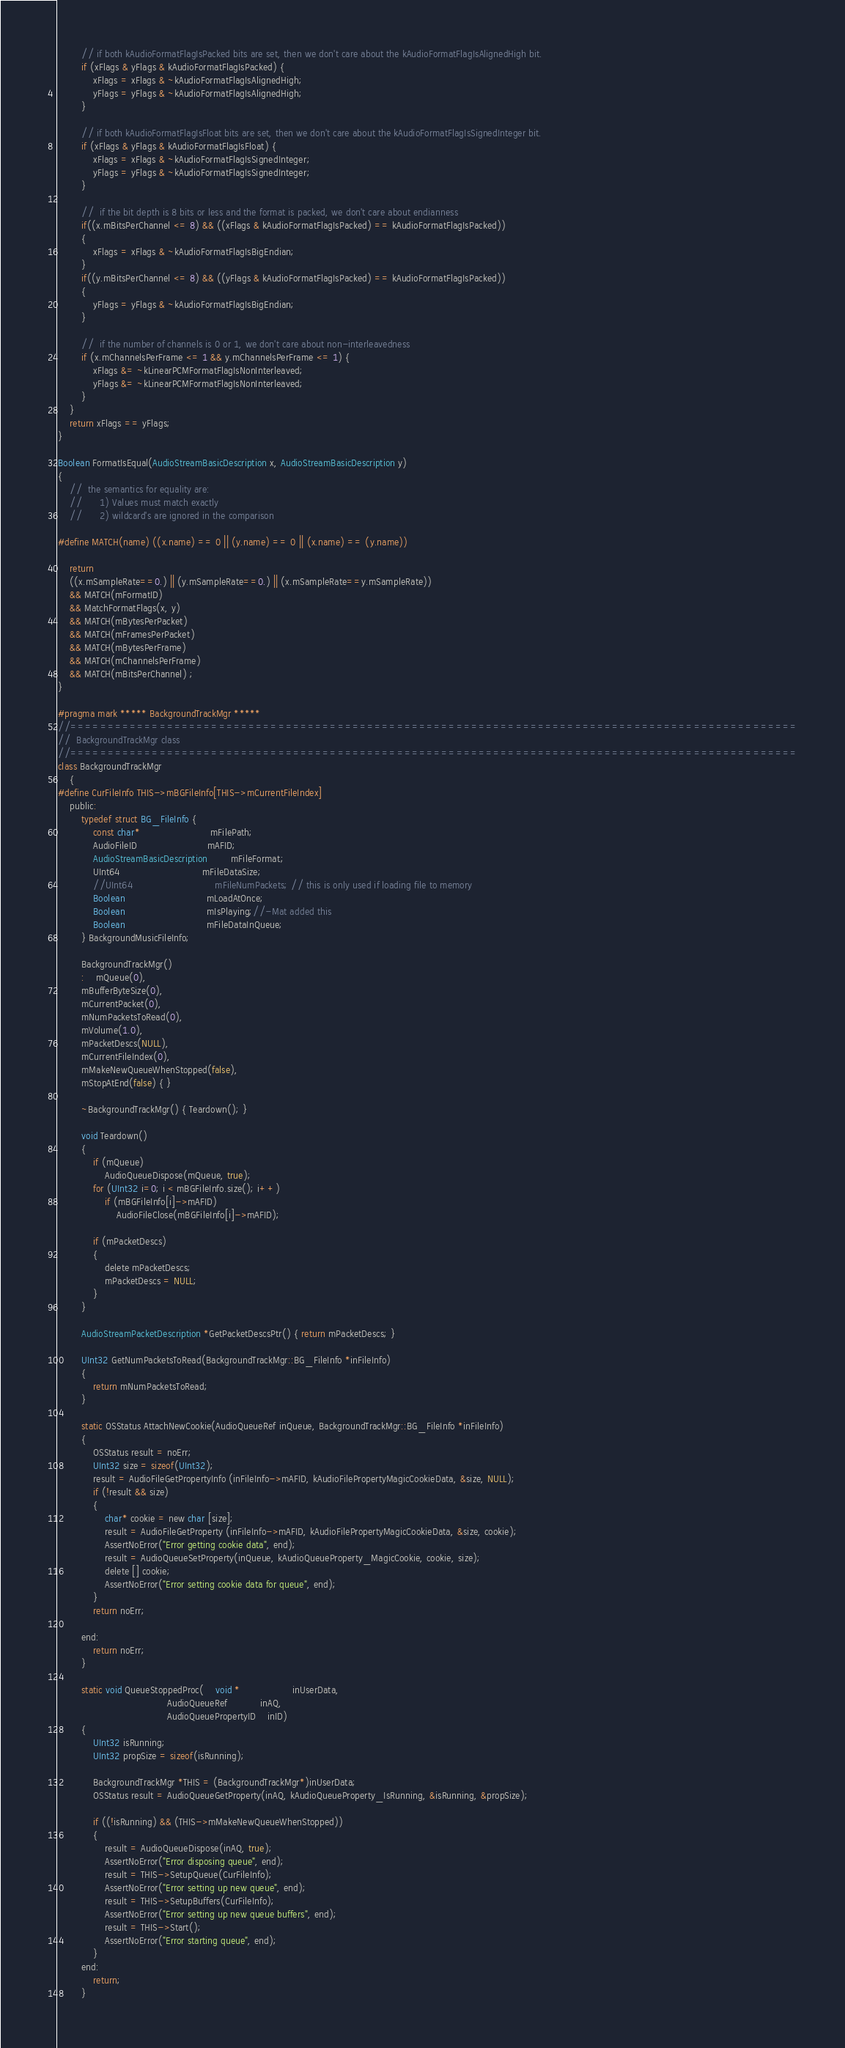<code> <loc_0><loc_0><loc_500><loc_500><_ObjectiveC_>        // if both kAudioFormatFlagIsPacked bits are set, then we don't care about the kAudioFormatFlagIsAlignedHigh bit.
        if (xFlags & yFlags & kAudioFormatFlagIsPacked) {
            xFlags = xFlags & ~kAudioFormatFlagIsAlignedHigh;
            yFlags = yFlags & ~kAudioFormatFlagIsAlignedHigh;
        }
        
        // if both kAudioFormatFlagIsFloat bits are set, then we don't care about the kAudioFormatFlagIsSignedInteger bit.
        if (xFlags & yFlags & kAudioFormatFlagIsFloat) {
            xFlags = xFlags & ~kAudioFormatFlagIsSignedInteger;
            yFlags = yFlags & ~kAudioFormatFlagIsSignedInteger;
        }
        
        //	if the bit depth is 8 bits or less and the format is packed, we don't care about endianness
        if((x.mBitsPerChannel <= 8) && ((xFlags & kAudioFormatFlagIsPacked) == kAudioFormatFlagIsPacked))
        {
            xFlags = xFlags & ~kAudioFormatFlagIsBigEndian;
        }
        if((y.mBitsPerChannel <= 8) && ((yFlags & kAudioFormatFlagIsPacked) == kAudioFormatFlagIsPacked))
        {
            yFlags = yFlags & ~kAudioFormatFlagIsBigEndian;
        }
        
        //	if the number of channels is 0 or 1, we don't care about non-interleavedness
        if (x.mChannelsPerFrame <= 1 && y.mChannelsPerFrame <= 1) {
            xFlags &= ~kLinearPCMFormatFlagIsNonInterleaved;
            yFlags &= ~kLinearPCMFormatFlagIsNonInterleaved;
        }
    }
    return xFlags == yFlags;
}

Boolean FormatIsEqual(AudioStreamBasicDescription x, AudioStreamBasicDescription y)
{
    //	the semantics for equality are:
    //		1) Values must match exactly
    //		2) wildcard's are ignored in the comparison
    
#define MATCH(name) ((x.name) == 0 || (y.name) == 0 || (x.name) == (y.name))
    
    return 
    ((x.mSampleRate==0.) || (y.mSampleRate==0.) || (x.mSampleRate==y.mSampleRate)) 
    && MATCH(mFormatID)
    && MatchFormatFlags(x, y)  
    && MATCH(mBytesPerPacket) 
    && MATCH(mFramesPerPacket) 
    && MATCH(mBytesPerFrame) 
    && MATCH(mChannelsPerFrame) 		
    && MATCH(mBitsPerChannel) ;
}

#pragma mark ***** BackgroundTrackMgr *****
//==================================================================================================
//	BackgroundTrackMgr class
//==================================================================================================
class BackgroundTrackMgr
    {	
#define CurFileInfo THIS->mBGFileInfo[THIS->mCurrentFileIndex]
    public:
        typedef struct BG_FileInfo {
            const char*						mFilePath;
            AudioFileID						mAFID;
            AudioStreamBasicDescription		mFileFormat;
            UInt64							mFileDataSize;
            //UInt64							mFileNumPackets; // this is only used if loading file to memory
            Boolean							mLoadAtOnce;
            Boolean							mIsPlaying;//-Mat added this
            Boolean							mFileDataInQueue;
        } BackgroundMusicFileInfo;
        
        BackgroundTrackMgr() 
        :	mQueue(0),
        mBufferByteSize(0),
        mCurrentPacket(0),
        mNumPacketsToRead(0),
        mVolume(1.0),
        mPacketDescs(NULL),
        mCurrentFileIndex(0),
        mMakeNewQueueWhenStopped(false),
        mStopAtEnd(false) { }
        
        ~BackgroundTrackMgr() { Teardown(); }
        
        void Teardown()
        {
            if (mQueue)
                AudioQueueDispose(mQueue, true);
            for (UInt32 i=0; i < mBGFileInfo.size(); i++)
                if (mBGFileInfo[i]->mAFID)
                    AudioFileClose(mBGFileInfo[i]->mAFID);
            
            if (mPacketDescs)
            {
                delete mPacketDescs;
                mPacketDescs = NULL;
            }
        }
        
        AudioStreamPacketDescription *GetPacketDescsPtr() { return mPacketDescs; }
        
        UInt32 GetNumPacketsToRead(BackgroundTrackMgr::BG_FileInfo *inFileInfo) 
        { 
            return mNumPacketsToRead; 
        }
        
        static OSStatus AttachNewCookie(AudioQueueRef inQueue, BackgroundTrackMgr::BG_FileInfo *inFileInfo)
        {
            OSStatus result = noErr;
            UInt32 size = sizeof(UInt32);
            result = AudioFileGetPropertyInfo (inFileInfo->mAFID, kAudioFilePropertyMagicCookieData, &size, NULL);
            if (!result && size) 
            {
                char* cookie = new char [size];		
                result = AudioFileGetProperty (inFileInfo->mAFID, kAudioFilePropertyMagicCookieData, &size, cookie);
                AssertNoError("Error getting cookie data", end);
                result = AudioQueueSetProperty(inQueue, kAudioQueueProperty_MagicCookie, cookie, size);
                delete [] cookie;
                AssertNoError("Error setting cookie data for queue", end);
            }
            return noErr;
            
        end:
            return noErr;
        }
        
        static void QueueStoppedProc(	void *                  inUserData,
                                     AudioQueueRef           inAQ,
                                     AudioQueuePropertyID    inID)
        {
            UInt32 isRunning;
            UInt32 propSize = sizeof(isRunning);
            
            BackgroundTrackMgr *THIS = (BackgroundTrackMgr*)inUserData;
            OSStatus result = AudioQueueGetProperty(inAQ, kAudioQueueProperty_IsRunning, &isRunning, &propSize);
            
            if ((!isRunning) && (THIS->mMakeNewQueueWhenStopped))
            {
                result = AudioQueueDispose(inAQ, true);
                AssertNoError("Error disposing queue", end);
                result = THIS->SetupQueue(CurFileInfo);
                AssertNoError("Error setting up new queue", end);
                result = THIS->SetupBuffers(CurFileInfo);
                AssertNoError("Error setting up new queue buffers", end);
                result = THIS->Start();
                AssertNoError("Error starting queue", end);
            }
        end:
            return;
        }</code> 